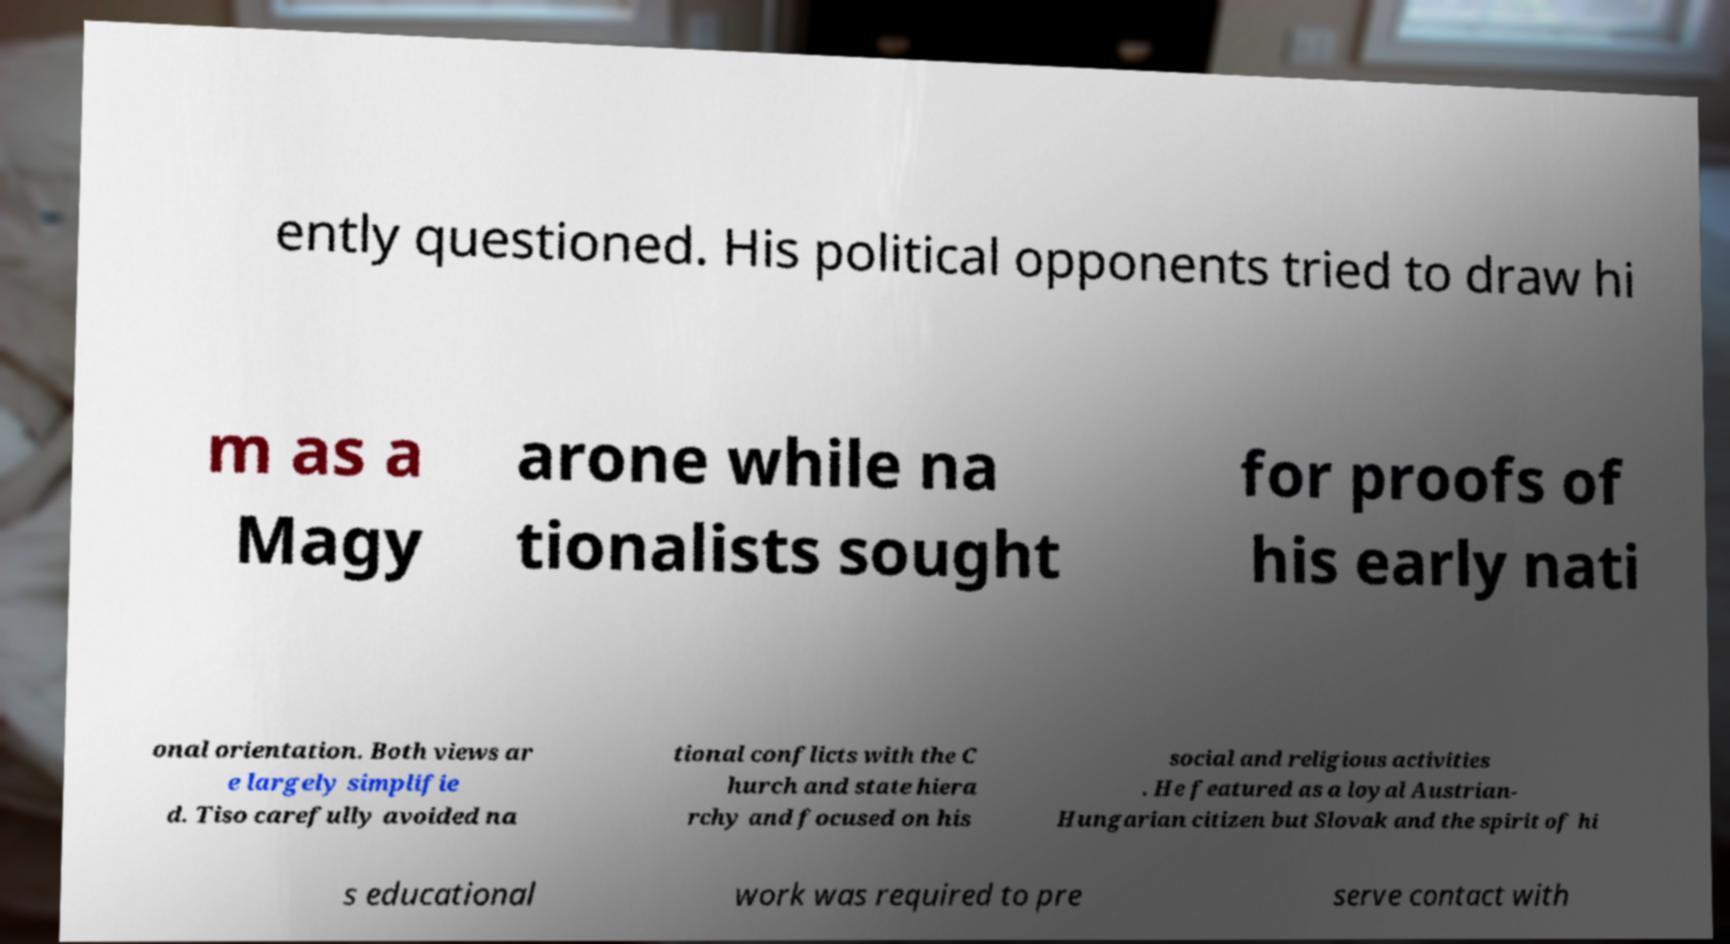Please identify and transcribe the text found in this image. ently questioned. His political opponents tried to draw hi m as a Magy arone while na tionalists sought for proofs of his early nati onal orientation. Both views ar e largely simplifie d. Tiso carefully avoided na tional conflicts with the C hurch and state hiera rchy and focused on his social and religious activities . He featured as a loyal Austrian- Hungarian citizen but Slovak and the spirit of hi s educational work was required to pre serve contact with 